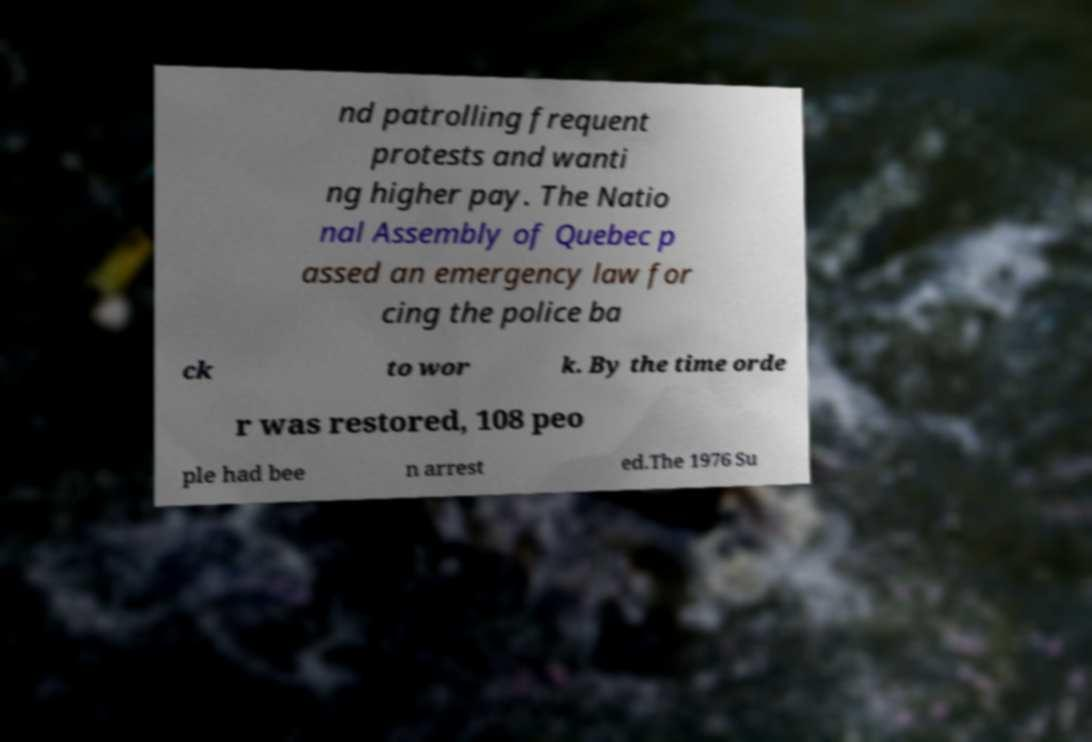For documentation purposes, I need the text within this image transcribed. Could you provide that? nd patrolling frequent protests and wanti ng higher pay. The Natio nal Assembly of Quebec p assed an emergency law for cing the police ba ck to wor k. By the time orde r was restored, 108 peo ple had bee n arrest ed.The 1976 Su 